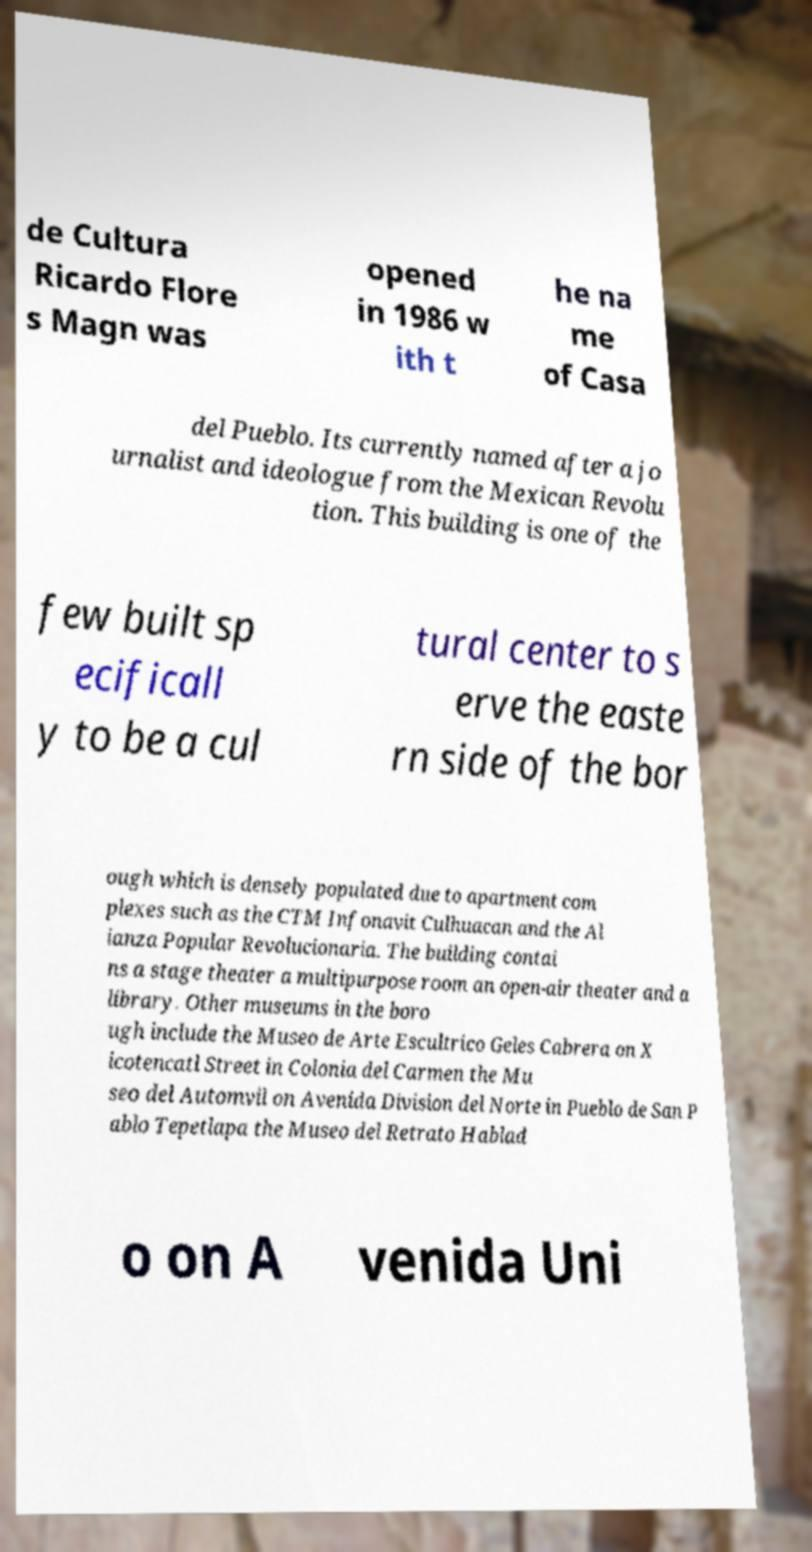For documentation purposes, I need the text within this image transcribed. Could you provide that? de Cultura Ricardo Flore s Magn was opened in 1986 w ith t he na me of Casa del Pueblo. Its currently named after a jo urnalist and ideologue from the Mexican Revolu tion. This building is one of the few built sp ecificall y to be a cul tural center to s erve the easte rn side of the bor ough which is densely populated due to apartment com plexes such as the CTM Infonavit Culhuacan and the Al ianza Popular Revolucionaria. The building contai ns a stage theater a multipurpose room an open-air theater and a library. Other museums in the boro ugh include the Museo de Arte Escultrico Geles Cabrera on X icotencatl Street in Colonia del Carmen the Mu seo del Automvil on Avenida Division del Norte in Pueblo de San P ablo Tepetlapa the Museo del Retrato Hablad o on A venida Uni 